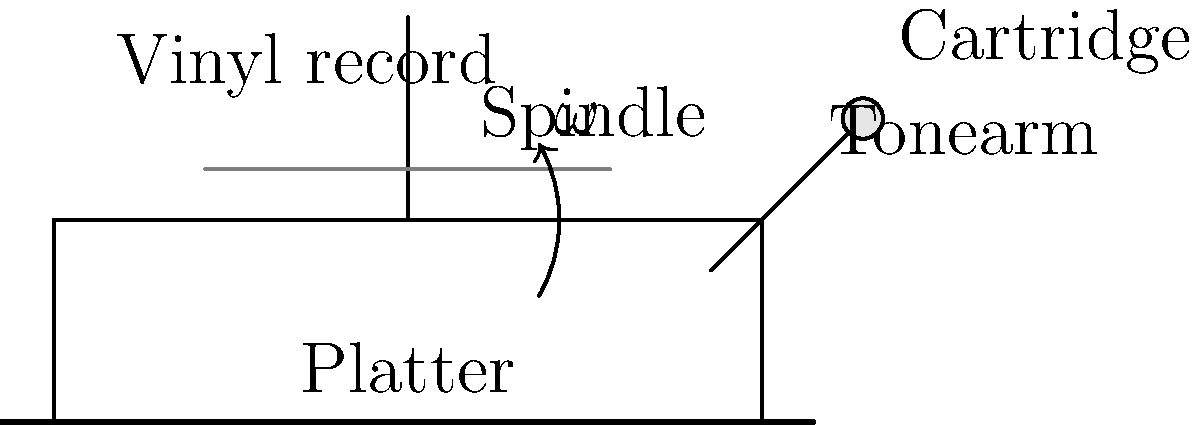In a vinyl record player, the platter rotates at a constant angular velocity $\omega$. If the diameter of a typical LP (Long Playing) record is 12 inches, what is the linear velocity (in inches per second) of a point on the outer edge of the record when it spins at 33 1/3 RPM? Let's approach this step-by-step:

1) First, we need to convert the angular velocity from RPM (revolutions per minute) to radians per second:
   $\omega = 33\frac{1}{3} \text{ RPM} = 33\frac{1}{3} \cdot \frac{2\pi}{60} \text{ rad/s} = \frac{2\pi}{1.8} \text{ rad/s}$

2) Now, we need to use the formula for linear velocity:
   $v = r\omega$
   Where $v$ is the linear velocity, $r$ is the radius, and $\omega$ is the angular velocity.

3) The diameter of the record is 12 inches, so the radius is 6 inches:
   $r = 6 \text{ inches}$

4) Plugging these values into our formula:
   $v = 6 \text{ inches} \cdot \frac{2\pi}{1.8} \text{ rad/s}$

5) Simplifying:
   $v = \frac{12\pi}{1.8} \text{ inches/s} = \frac{20\pi}{3} \text{ inches/s}$

6) Calculating the final value:
   $v \approx 20.94 \text{ inches/s}$
Answer: $\frac{20\pi}{3} \text{ inches/s}$ (or approximately 20.94 inches/s) 